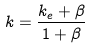Convert formula to latex. <formula><loc_0><loc_0><loc_500><loc_500>k = \frac { k _ { e } + \beta } { 1 + \beta }</formula> 